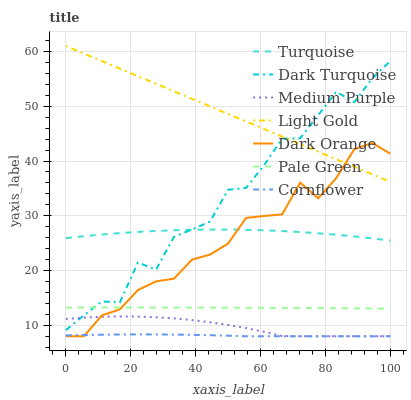Does Cornflower have the minimum area under the curve?
Answer yes or no. Yes. Does Light Gold have the maximum area under the curve?
Answer yes or no. Yes. Does Turquoise have the minimum area under the curve?
Answer yes or no. No. Does Turquoise have the maximum area under the curve?
Answer yes or no. No. Is Light Gold the smoothest?
Answer yes or no. Yes. Is Dark Turquoise the roughest?
Answer yes or no. Yes. Is Turquoise the smoothest?
Answer yes or no. No. Is Turquoise the roughest?
Answer yes or no. No. Does Turquoise have the lowest value?
Answer yes or no. No. Does Light Gold have the highest value?
Answer yes or no. Yes. Does Turquoise have the highest value?
Answer yes or no. No. Is Pale Green less than Turquoise?
Answer yes or no. Yes. Is Light Gold greater than Cornflower?
Answer yes or no. Yes. Does Medium Purple intersect Dark Orange?
Answer yes or no. Yes. Is Medium Purple less than Dark Orange?
Answer yes or no. No. Is Medium Purple greater than Dark Orange?
Answer yes or no. No. Does Pale Green intersect Turquoise?
Answer yes or no. No. 